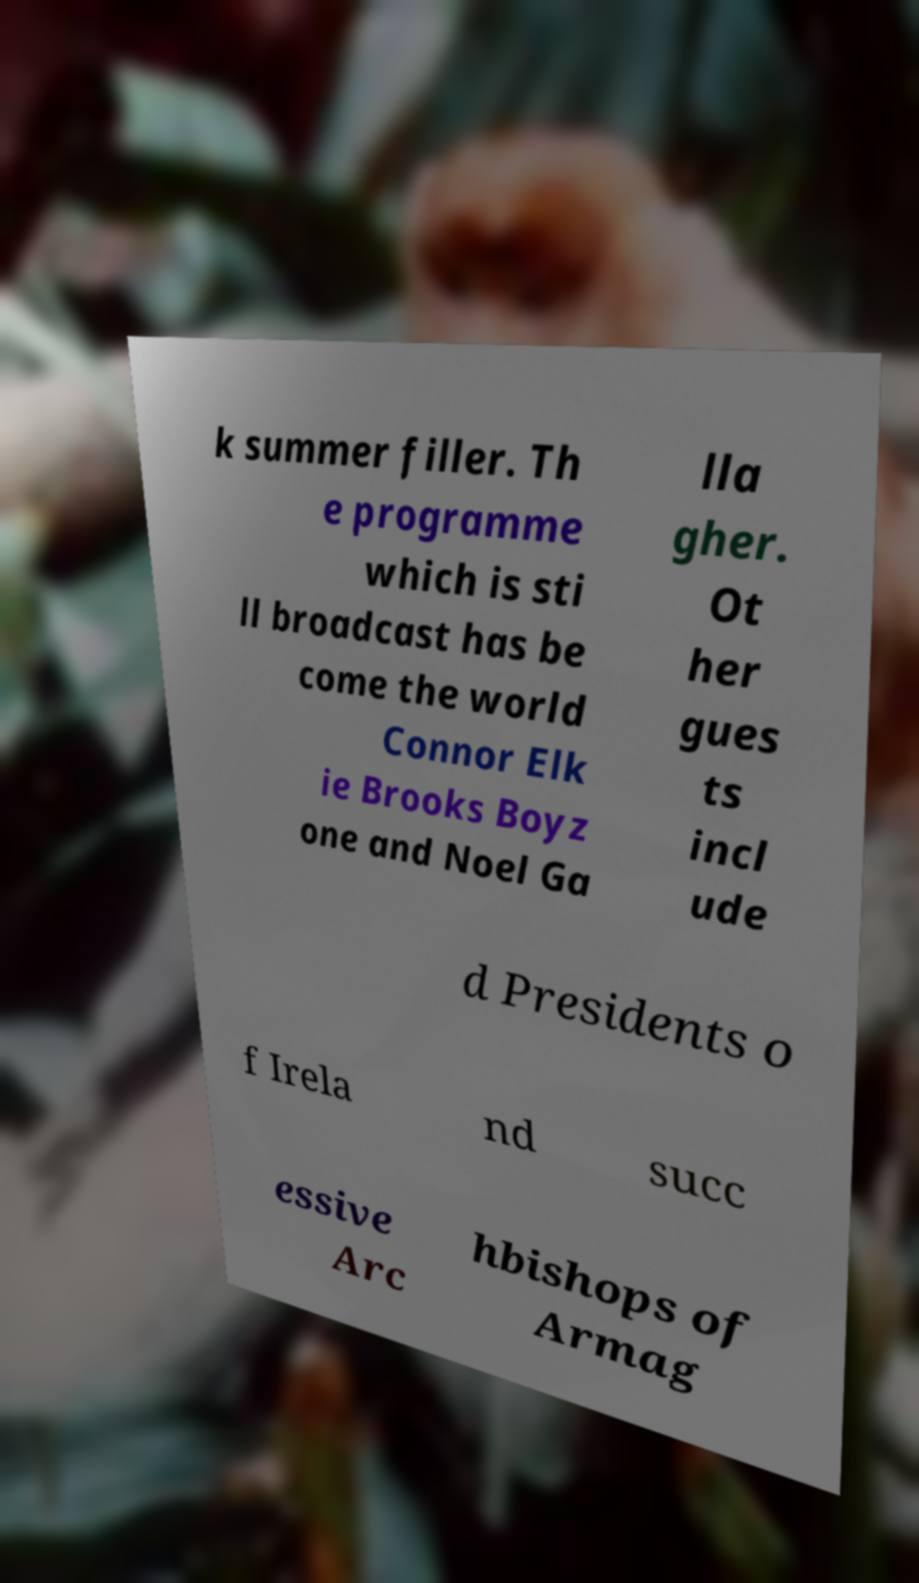Can you accurately transcribe the text from the provided image for me? k summer filler. Th e programme which is sti ll broadcast has be come the world Connor Elk ie Brooks Boyz one and Noel Ga lla gher. Ot her gues ts incl ude d Presidents o f Irela nd succ essive Arc hbishops of Armag 